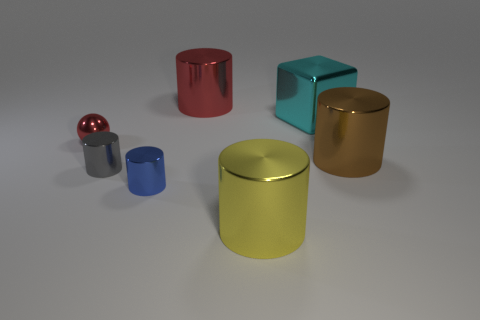Subtract all blue cylinders. How many cylinders are left? 4 Subtract all small blue metal cylinders. How many cylinders are left? 4 Subtract 4 cylinders. How many cylinders are left? 1 Subtract all yellow metallic cylinders. Subtract all cyan blocks. How many objects are left? 5 Add 7 small metal objects. How many small metal objects are left? 10 Add 3 metallic cubes. How many metallic cubes exist? 4 Add 2 small rubber things. How many objects exist? 9 Subtract 0 green spheres. How many objects are left? 7 Subtract all spheres. How many objects are left? 6 Subtract all purple cylinders. Subtract all red cubes. How many cylinders are left? 5 